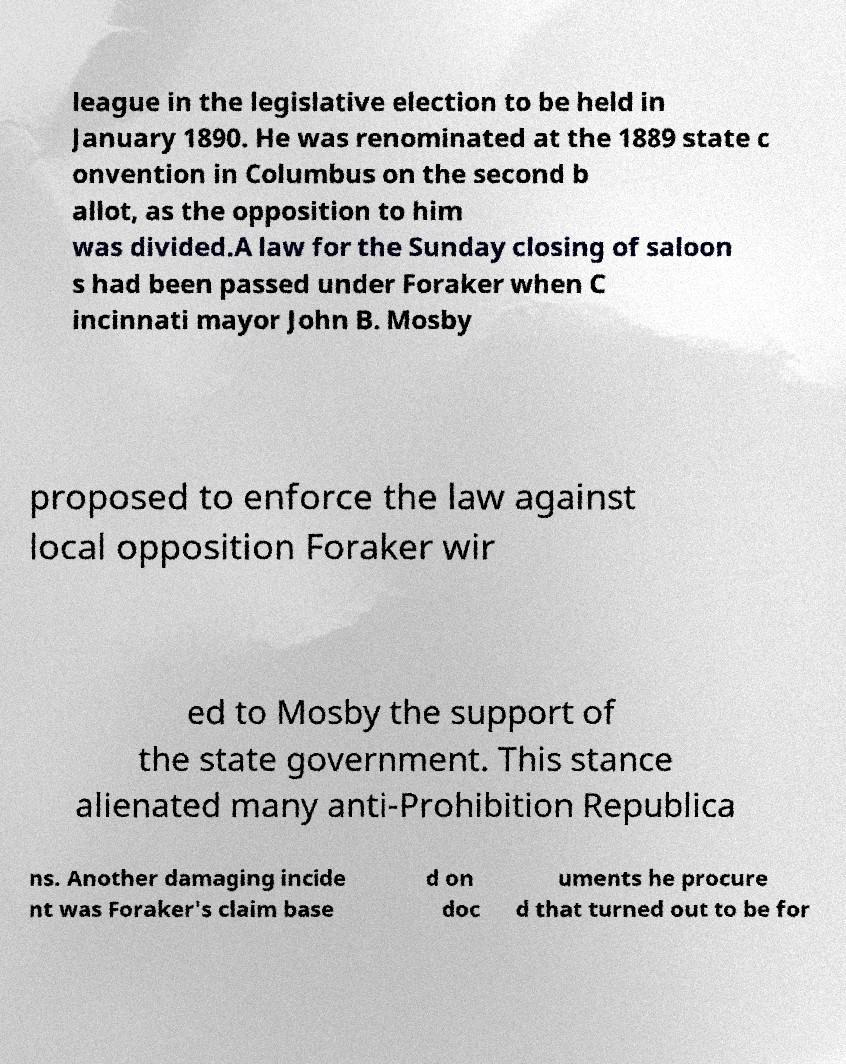Could you extract and type out the text from this image? league in the legislative election to be held in January 1890. He was renominated at the 1889 state c onvention in Columbus on the second b allot, as the opposition to him was divided.A law for the Sunday closing of saloon s had been passed under Foraker when C incinnati mayor John B. Mosby proposed to enforce the law against local opposition Foraker wir ed to Mosby the support of the state government. This stance alienated many anti-Prohibition Republica ns. Another damaging incide nt was Foraker's claim base d on doc uments he procure d that turned out to be for 